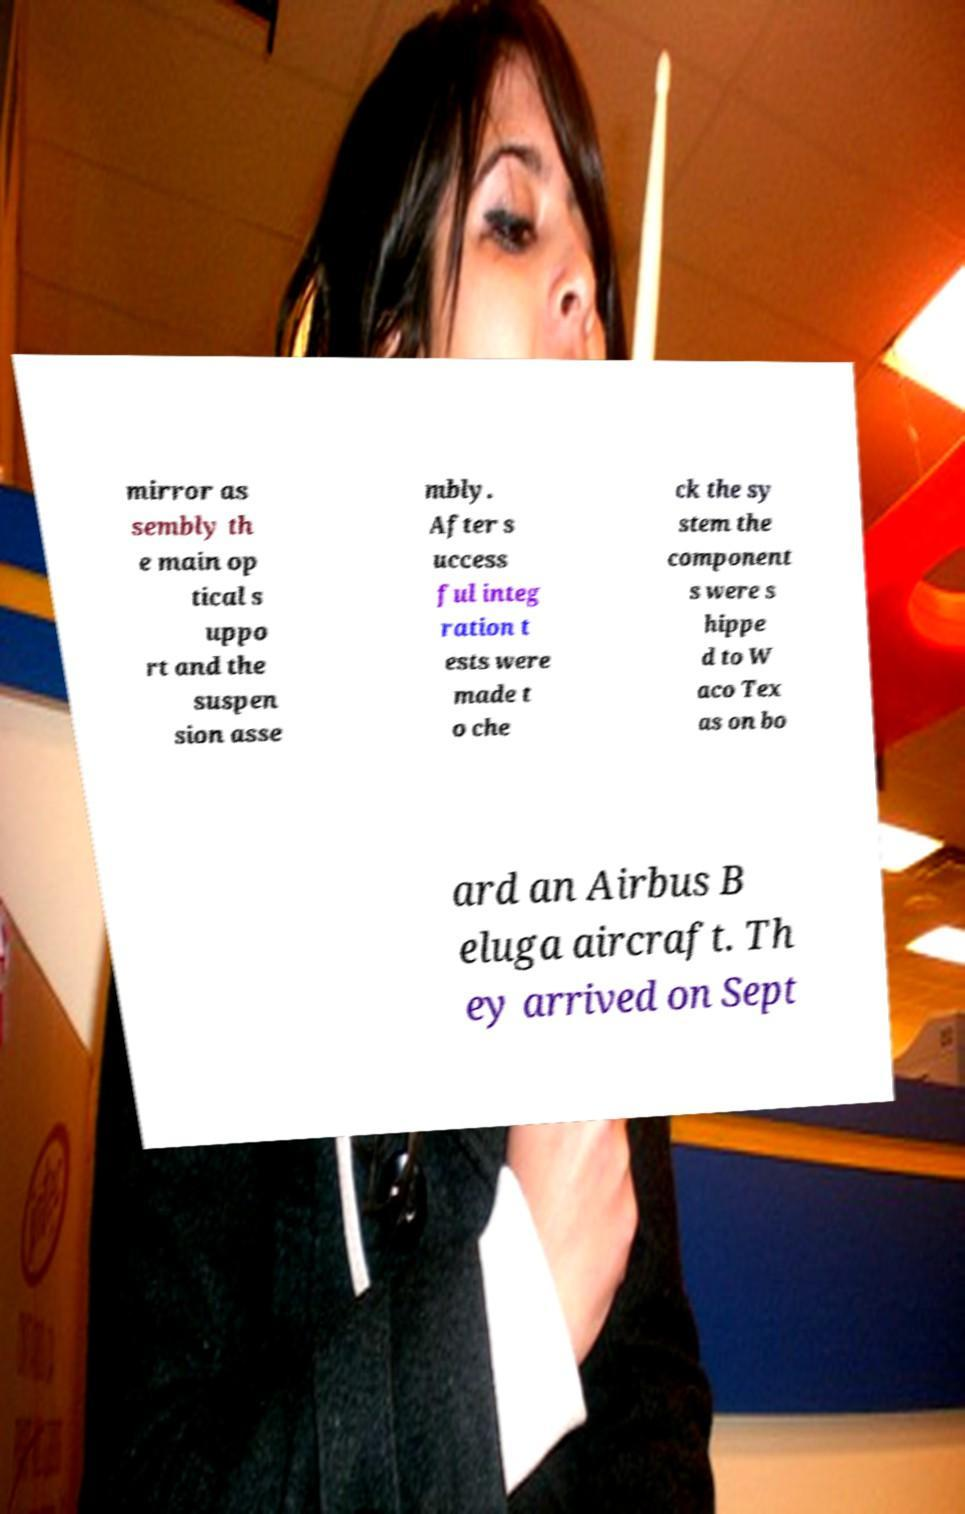Please identify and transcribe the text found in this image. mirror as sembly th e main op tical s uppo rt and the suspen sion asse mbly. After s uccess ful integ ration t ests were made t o che ck the sy stem the component s were s hippe d to W aco Tex as on bo ard an Airbus B eluga aircraft. Th ey arrived on Sept 